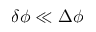<formula> <loc_0><loc_0><loc_500><loc_500>\delta \phi \ll \Delta \phi</formula> 